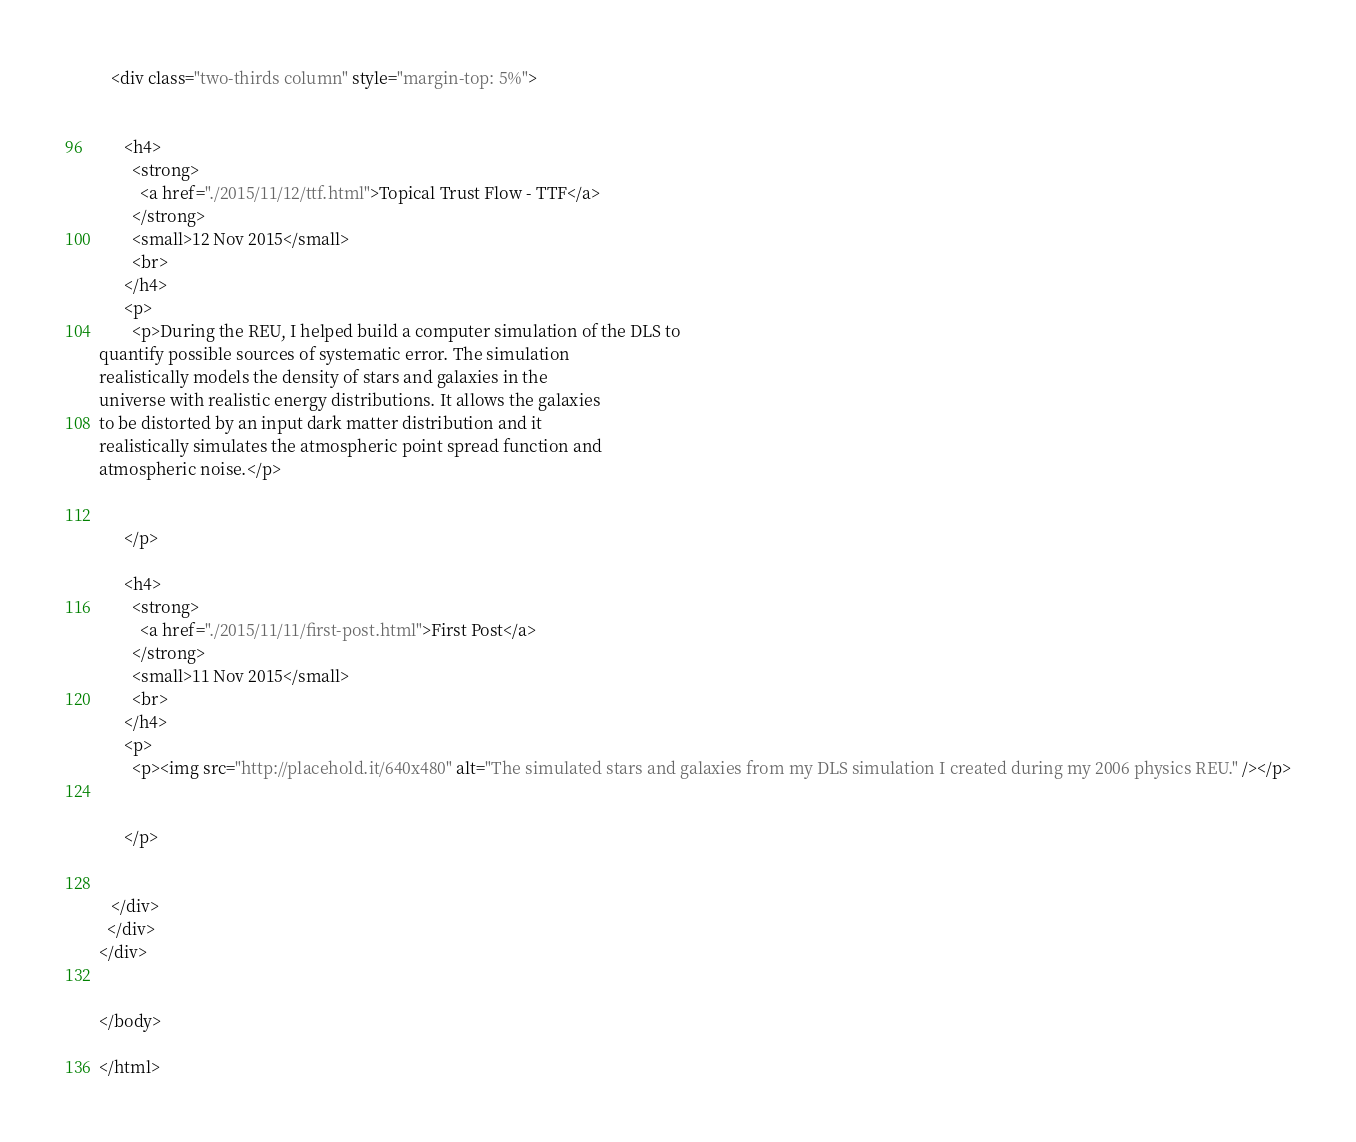Convert code to text. <code><loc_0><loc_0><loc_500><loc_500><_HTML_>   <div class="two-thirds column" style="margin-top: 5%">

    
      <h4>
        <strong>
          <a href="./2015/11/12/ttf.html">Topical Trust Flow - TTF</a>
        </strong>
        <small>12 Nov 2015</small>
        <br>
      </h4>
      <p>
        <p>During the REU, I helped build a computer simulation of the DLS to
quantify possible sources of systematic error. The simulation
realistically models the density of stars and galaxies in the
universe with realistic energy distributions. It allows the galaxies
to be distorted by an input dark matter distribution and it
realistically simulates the atmospheric point spread function and
atmospheric noise.</p>


      </p>
    
      <h4>
        <strong>
          <a href="./2015/11/11/first-post.html">First Post</a>
        </strong>
        <small>11 Nov 2015</small>
        <br>
      </h4>
      <p>
        <p><img src="http://placehold.it/640x480" alt="The simulated stars and galaxies from my DLS simulation I created during my 2006 physics REU." /></p>


      </p>
    

   </div>
  </div>
</div>


</body>

</html>
</code> 